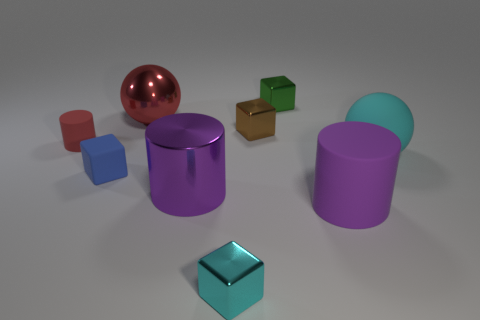Add 1 rubber blocks. How many objects exist? 10 Subtract all spheres. How many objects are left? 7 Subtract all matte blocks. Subtract all small rubber cubes. How many objects are left? 7 Add 3 tiny blue objects. How many tiny blue objects are left? 4 Add 7 brown things. How many brown things exist? 8 Subtract 0 gray cylinders. How many objects are left? 9 